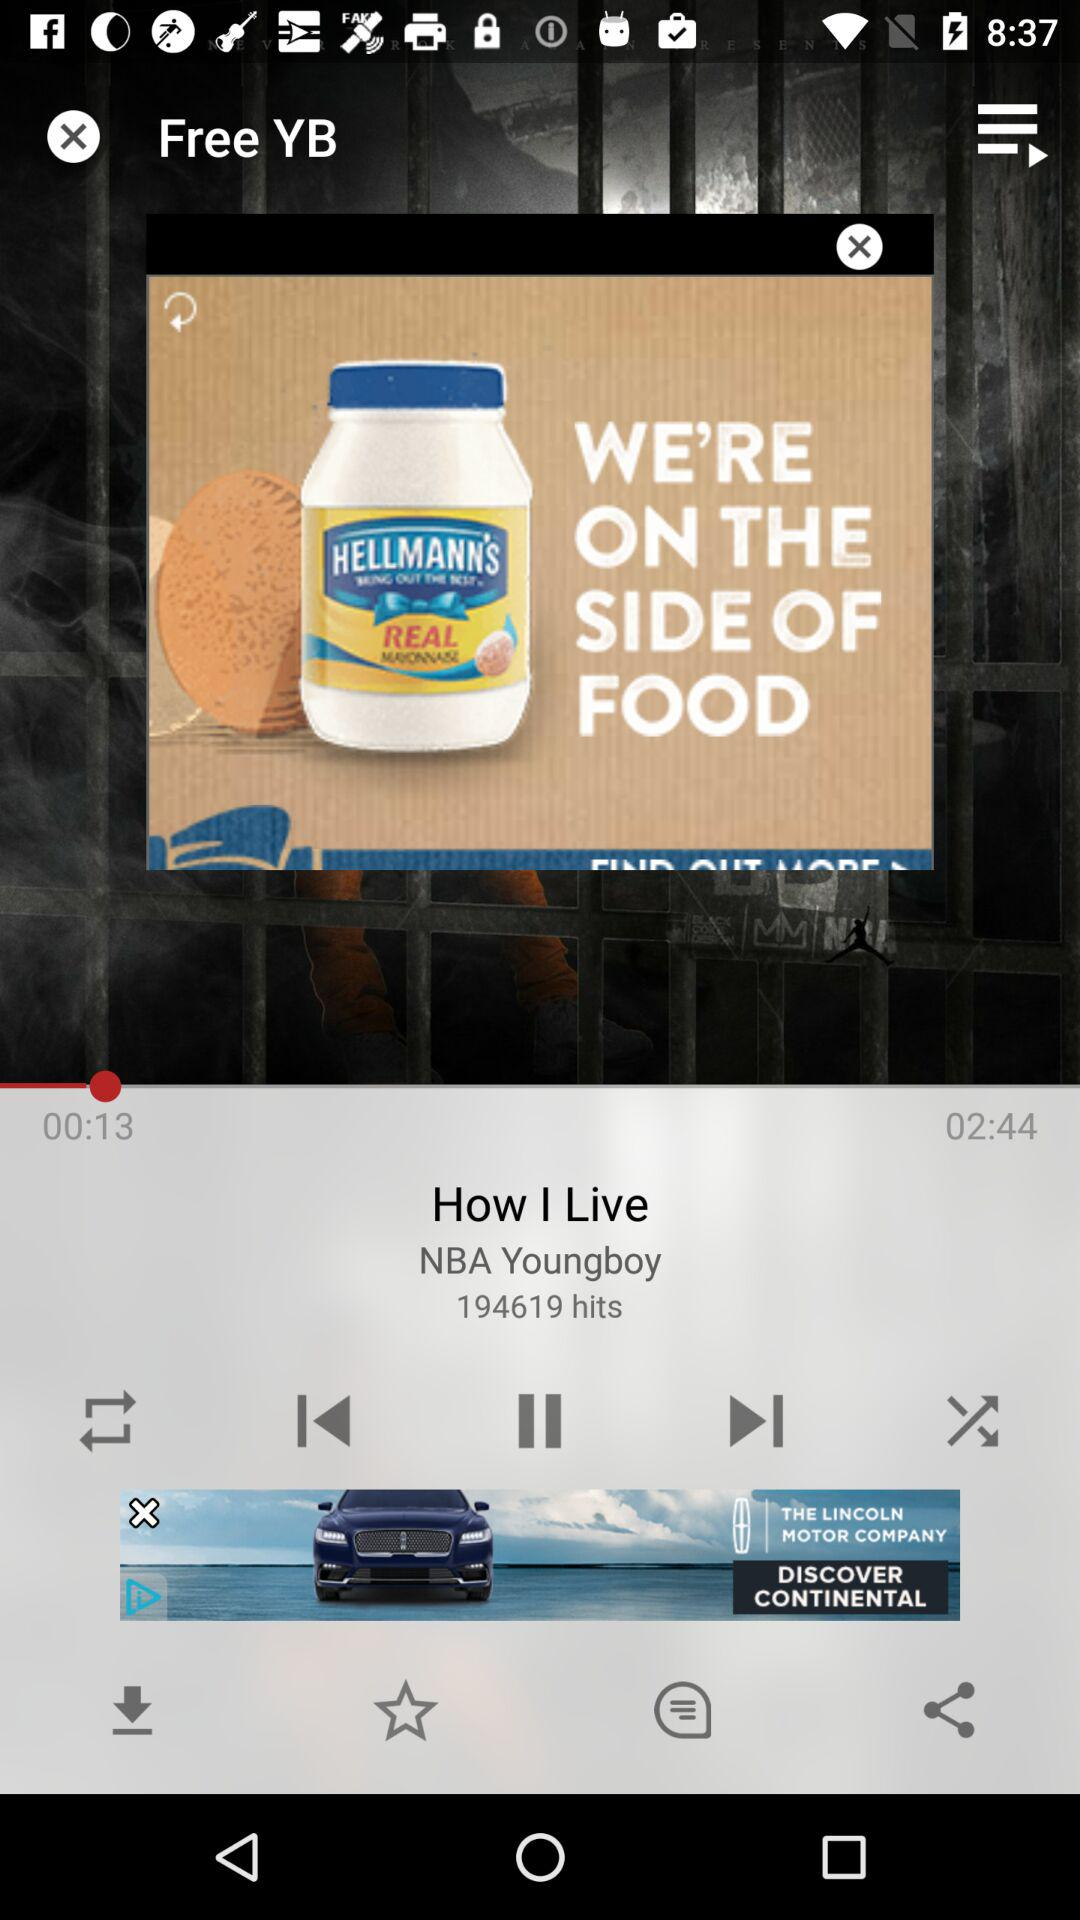What is the number of hits? The number of hits is 194619. 